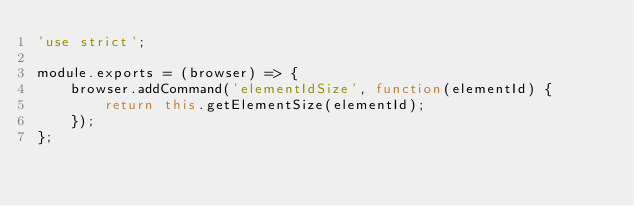Convert code to text. <code><loc_0><loc_0><loc_500><loc_500><_JavaScript_>'use strict';

module.exports = (browser) => {
    browser.addCommand('elementIdSize', function(elementId) {
        return this.getElementSize(elementId);
    });
};
</code> 